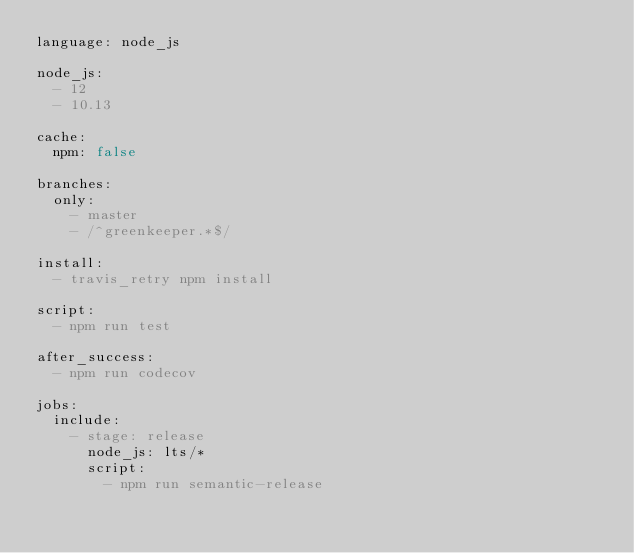<code> <loc_0><loc_0><loc_500><loc_500><_YAML_>language: node_js

node_js:
  - 12
  - 10.13

cache:
  npm: false

branches:
  only:
    - master
    - /^greenkeeper.*$/

install:
  - travis_retry npm install

script:
  - npm run test

after_success:
  - npm run codecov

jobs:
  include:
    - stage: release
      node_js: lts/*
      script:
        - npm run semantic-release
</code> 